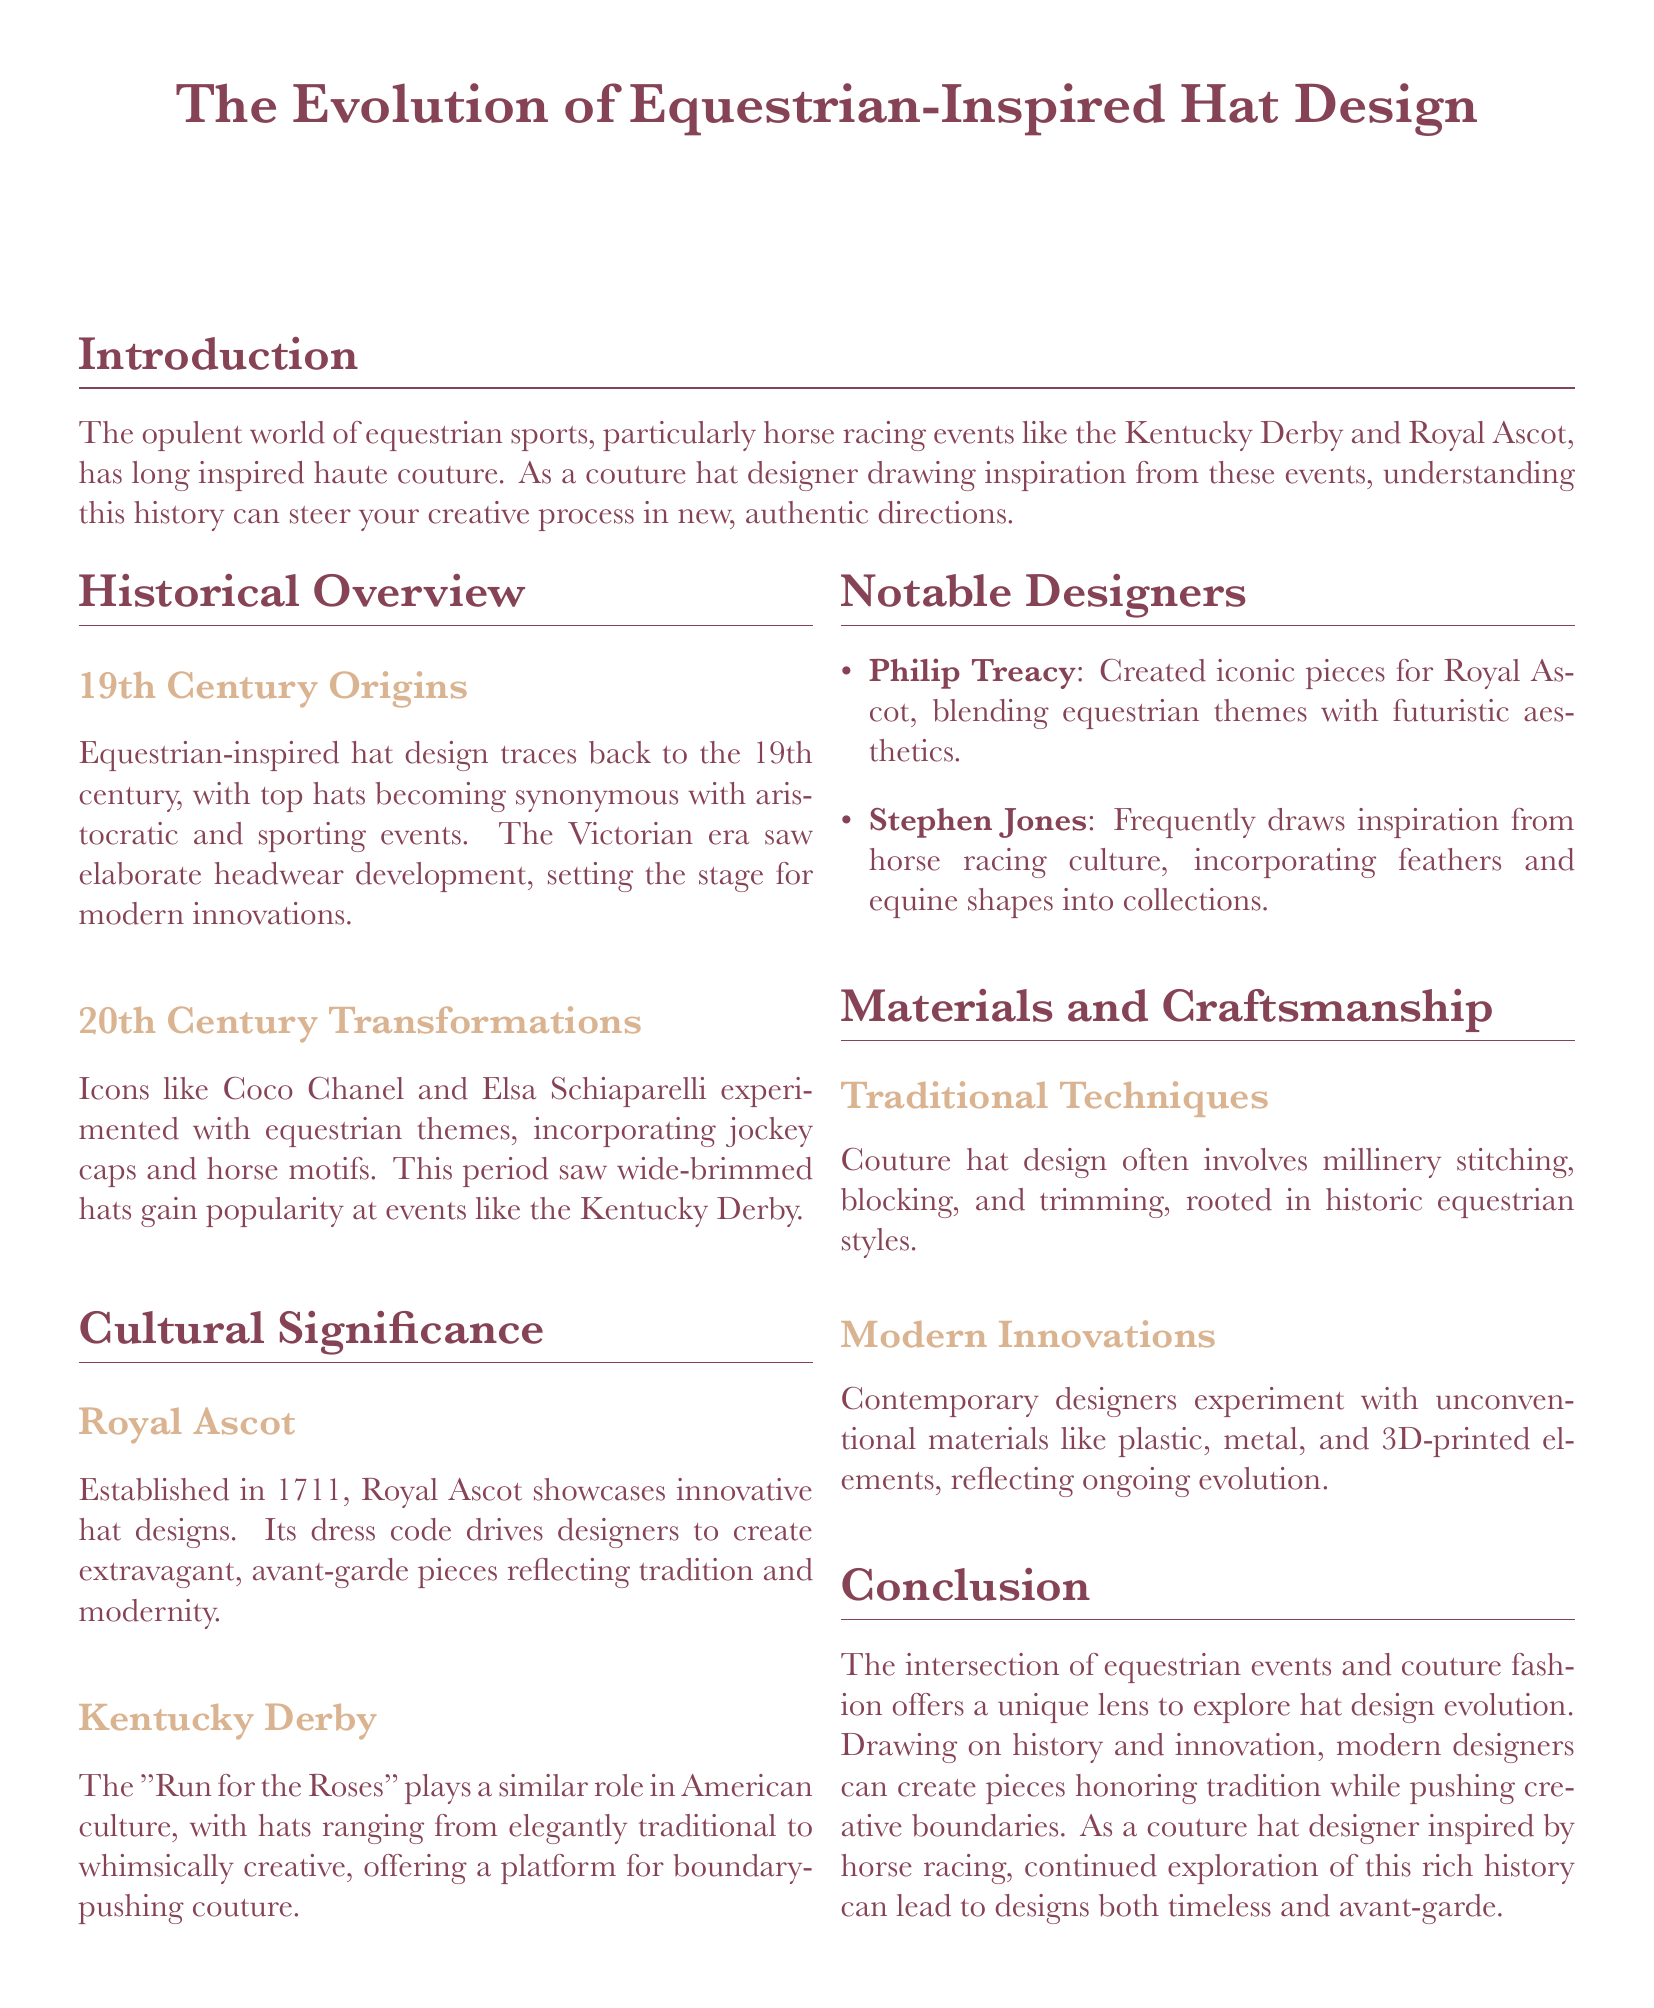What are the two iconic racing events mentioned? The document highlights the Kentucky Derby and Royal Ascot as significant events in equestrian sports.
Answer: Kentucky Derby and Royal Ascot Who were two notable designers mentioned in the document? The document lists Philip Treacy and Stephen Jones as notable designers in couture hat design inspired by equestrian themes.
Answer: Philip Treacy and Stephen Jones In which century did equestrian-inspired hat design originate? The document indicates that the origins of equestrian-inspired hat design can be traced back to the 19th century.
Answer: 19th century What type of hats gained popularity in the 20th century at horse racing events? The document states that wide-brimmed hats became popular at events like the Kentucky Derby during the 20th century.
Answer: Wide-brimmed hats What year was Royal Ascot established? According to the document, Royal Ascot was established in 1711.
Answer: 1711 What is one modern material mentioned that designers experiment with in hat design? The document notes that contemporary designers use materials like plastic in their hat designs.
Answer: Plastic How does the Royal Ascot's dress code influence designers? The dress code at Royal Ascot drives designers to create extravagant and avant-garde pieces, reflecting tradition and modernity.
Answer: Extravagant and avant-garde pieces What specific traditional technique is mentioned in hat making? The document mentions millinery stitching as a traditional technique used in couture hat design.
Answer: Millinery stitching What does the conclusion emphasize about modern designers? The conclusion emphasizes that modern designers can create pieces that honor tradition while pushing creative boundaries.
Answer: Honor tradition while pushing creative boundaries 